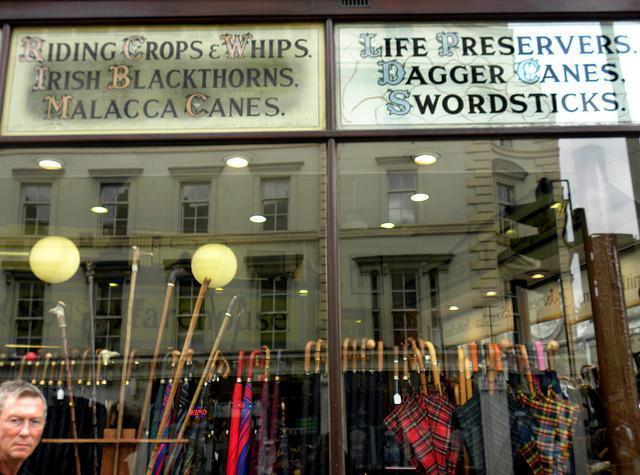How many men are shown?
Give a very brief answer. 1. How many umbrellas can be seen?
Give a very brief answer. 5. 